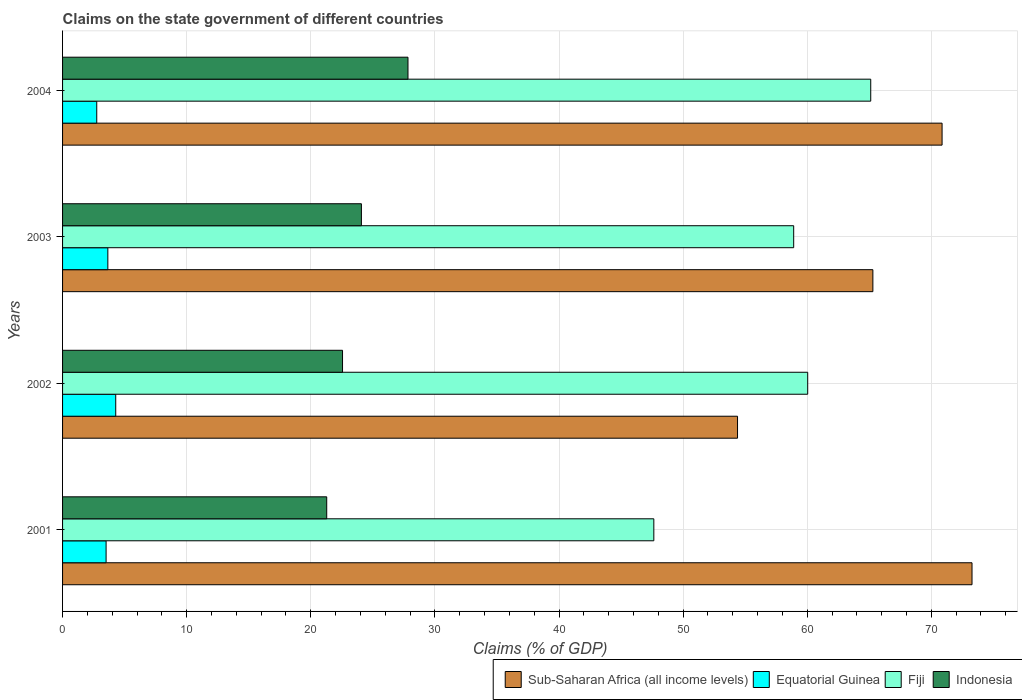How many groups of bars are there?
Offer a terse response. 4. Are the number of bars per tick equal to the number of legend labels?
Make the answer very short. Yes. How many bars are there on the 1st tick from the bottom?
Provide a succinct answer. 4. In how many cases, is the number of bars for a given year not equal to the number of legend labels?
Provide a short and direct response. 0. What is the percentage of GDP claimed on the state government in Sub-Saharan Africa (all income levels) in 2001?
Make the answer very short. 73.28. Across all years, what is the maximum percentage of GDP claimed on the state government in Equatorial Guinea?
Keep it short and to the point. 4.28. Across all years, what is the minimum percentage of GDP claimed on the state government in Indonesia?
Your response must be concise. 21.28. In which year was the percentage of GDP claimed on the state government in Indonesia minimum?
Give a very brief answer. 2001. What is the total percentage of GDP claimed on the state government in Equatorial Guinea in the graph?
Your answer should be very brief. 14.19. What is the difference between the percentage of GDP claimed on the state government in Indonesia in 2001 and that in 2002?
Your response must be concise. -1.27. What is the difference between the percentage of GDP claimed on the state government in Equatorial Guinea in 2001 and the percentage of GDP claimed on the state government in Fiji in 2002?
Offer a very short reply. -56.53. What is the average percentage of GDP claimed on the state government in Sub-Saharan Africa (all income levels) per year?
Offer a very short reply. 65.95. In the year 2004, what is the difference between the percentage of GDP claimed on the state government in Fiji and percentage of GDP claimed on the state government in Sub-Saharan Africa (all income levels)?
Give a very brief answer. -5.75. In how many years, is the percentage of GDP claimed on the state government in Fiji greater than 6 %?
Offer a terse response. 4. What is the ratio of the percentage of GDP claimed on the state government in Fiji in 2003 to that in 2004?
Give a very brief answer. 0.9. What is the difference between the highest and the second highest percentage of GDP claimed on the state government in Fiji?
Make the answer very short. 5.08. What is the difference between the highest and the lowest percentage of GDP claimed on the state government in Fiji?
Provide a succinct answer. 17.48. In how many years, is the percentage of GDP claimed on the state government in Indonesia greater than the average percentage of GDP claimed on the state government in Indonesia taken over all years?
Keep it short and to the point. 2. Is the sum of the percentage of GDP claimed on the state government in Fiji in 2001 and 2003 greater than the maximum percentage of GDP claimed on the state government in Equatorial Guinea across all years?
Provide a succinct answer. Yes. What does the 3rd bar from the top in 2003 represents?
Ensure brevity in your answer.  Equatorial Guinea. What does the 4th bar from the bottom in 2001 represents?
Give a very brief answer. Indonesia. How many bars are there?
Provide a succinct answer. 16. How many years are there in the graph?
Ensure brevity in your answer.  4. What is the difference between two consecutive major ticks on the X-axis?
Offer a very short reply. 10. Are the values on the major ticks of X-axis written in scientific E-notation?
Your answer should be very brief. No. Does the graph contain any zero values?
Your answer should be very brief. No. Where does the legend appear in the graph?
Offer a terse response. Bottom right. How many legend labels are there?
Your answer should be compact. 4. How are the legend labels stacked?
Give a very brief answer. Horizontal. What is the title of the graph?
Give a very brief answer. Claims on the state government of different countries. Does "Russian Federation" appear as one of the legend labels in the graph?
Your answer should be very brief. No. What is the label or title of the X-axis?
Provide a succinct answer. Claims (% of GDP). What is the label or title of the Y-axis?
Your response must be concise. Years. What is the Claims (% of GDP) in Sub-Saharan Africa (all income levels) in 2001?
Your answer should be compact. 73.28. What is the Claims (% of GDP) in Equatorial Guinea in 2001?
Your answer should be compact. 3.51. What is the Claims (% of GDP) in Fiji in 2001?
Make the answer very short. 47.64. What is the Claims (% of GDP) in Indonesia in 2001?
Your response must be concise. 21.28. What is the Claims (% of GDP) in Sub-Saharan Africa (all income levels) in 2002?
Ensure brevity in your answer.  54.38. What is the Claims (% of GDP) in Equatorial Guinea in 2002?
Your answer should be very brief. 4.28. What is the Claims (% of GDP) of Fiji in 2002?
Offer a terse response. 60.04. What is the Claims (% of GDP) of Indonesia in 2002?
Make the answer very short. 22.56. What is the Claims (% of GDP) in Sub-Saharan Africa (all income levels) in 2003?
Your response must be concise. 65.29. What is the Claims (% of GDP) in Equatorial Guinea in 2003?
Your answer should be compact. 3.65. What is the Claims (% of GDP) of Fiji in 2003?
Make the answer very short. 58.91. What is the Claims (% of GDP) in Indonesia in 2003?
Make the answer very short. 24.08. What is the Claims (% of GDP) of Sub-Saharan Africa (all income levels) in 2004?
Keep it short and to the point. 70.86. What is the Claims (% of GDP) in Equatorial Guinea in 2004?
Provide a short and direct response. 2.75. What is the Claims (% of GDP) in Fiji in 2004?
Give a very brief answer. 65.12. What is the Claims (% of GDP) of Indonesia in 2004?
Your response must be concise. 27.83. Across all years, what is the maximum Claims (% of GDP) of Sub-Saharan Africa (all income levels)?
Your answer should be compact. 73.28. Across all years, what is the maximum Claims (% of GDP) in Equatorial Guinea?
Offer a terse response. 4.28. Across all years, what is the maximum Claims (% of GDP) in Fiji?
Your answer should be compact. 65.12. Across all years, what is the maximum Claims (% of GDP) of Indonesia?
Offer a terse response. 27.83. Across all years, what is the minimum Claims (% of GDP) in Sub-Saharan Africa (all income levels)?
Keep it short and to the point. 54.38. Across all years, what is the minimum Claims (% of GDP) of Equatorial Guinea?
Keep it short and to the point. 2.75. Across all years, what is the minimum Claims (% of GDP) in Fiji?
Your response must be concise. 47.64. Across all years, what is the minimum Claims (% of GDP) of Indonesia?
Give a very brief answer. 21.28. What is the total Claims (% of GDP) in Sub-Saharan Africa (all income levels) in the graph?
Give a very brief answer. 263.81. What is the total Claims (% of GDP) of Equatorial Guinea in the graph?
Keep it short and to the point. 14.19. What is the total Claims (% of GDP) of Fiji in the graph?
Keep it short and to the point. 231.7. What is the total Claims (% of GDP) in Indonesia in the graph?
Offer a terse response. 95.75. What is the difference between the Claims (% of GDP) of Sub-Saharan Africa (all income levels) in 2001 and that in 2002?
Ensure brevity in your answer.  18.89. What is the difference between the Claims (% of GDP) of Equatorial Guinea in 2001 and that in 2002?
Make the answer very short. -0.78. What is the difference between the Claims (% of GDP) of Fiji in 2001 and that in 2002?
Make the answer very short. -12.4. What is the difference between the Claims (% of GDP) of Indonesia in 2001 and that in 2002?
Your response must be concise. -1.27. What is the difference between the Claims (% of GDP) of Sub-Saharan Africa (all income levels) in 2001 and that in 2003?
Give a very brief answer. 7.99. What is the difference between the Claims (% of GDP) in Equatorial Guinea in 2001 and that in 2003?
Give a very brief answer. -0.14. What is the difference between the Claims (% of GDP) of Fiji in 2001 and that in 2003?
Offer a very short reply. -11.27. What is the difference between the Claims (% of GDP) in Indonesia in 2001 and that in 2003?
Your answer should be very brief. -2.8. What is the difference between the Claims (% of GDP) of Sub-Saharan Africa (all income levels) in 2001 and that in 2004?
Make the answer very short. 2.41. What is the difference between the Claims (% of GDP) of Equatorial Guinea in 2001 and that in 2004?
Give a very brief answer. 0.75. What is the difference between the Claims (% of GDP) in Fiji in 2001 and that in 2004?
Ensure brevity in your answer.  -17.48. What is the difference between the Claims (% of GDP) in Indonesia in 2001 and that in 2004?
Keep it short and to the point. -6.55. What is the difference between the Claims (% of GDP) in Sub-Saharan Africa (all income levels) in 2002 and that in 2003?
Your answer should be compact. -10.9. What is the difference between the Claims (% of GDP) of Equatorial Guinea in 2002 and that in 2003?
Your answer should be very brief. 0.64. What is the difference between the Claims (% of GDP) in Fiji in 2002 and that in 2003?
Make the answer very short. 1.13. What is the difference between the Claims (% of GDP) of Indonesia in 2002 and that in 2003?
Ensure brevity in your answer.  -1.52. What is the difference between the Claims (% of GDP) in Sub-Saharan Africa (all income levels) in 2002 and that in 2004?
Give a very brief answer. -16.48. What is the difference between the Claims (% of GDP) in Equatorial Guinea in 2002 and that in 2004?
Provide a succinct answer. 1.53. What is the difference between the Claims (% of GDP) of Fiji in 2002 and that in 2004?
Your response must be concise. -5.08. What is the difference between the Claims (% of GDP) in Indonesia in 2002 and that in 2004?
Make the answer very short. -5.27. What is the difference between the Claims (% of GDP) of Sub-Saharan Africa (all income levels) in 2003 and that in 2004?
Offer a terse response. -5.58. What is the difference between the Claims (% of GDP) of Equatorial Guinea in 2003 and that in 2004?
Offer a very short reply. 0.89. What is the difference between the Claims (% of GDP) in Fiji in 2003 and that in 2004?
Ensure brevity in your answer.  -6.21. What is the difference between the Claims (% of GDP) of Indonesia in 2003 and that in 2004?
Make the answer very short. -3.75. What is the difference between the Claims (% of GDP) of Sub-Saharan Africa (all income levels) in 2001 and the Claims (% of GDP) of Equatorial Guinea in 2002?
Offer a very short reply. 68.99. What is the difference between the Claims (% of GDP) of Sub-Saharan Africa (all income levels) in 2001 and the Claims (% of GDP) of Fiji in 2002?
Provide a succinct answer. 13.24. What is the difference between the Claims (% of GDP) of Sub-Saharan Africa (all income levels) in 2001 and the Claims (% of GDP) of Indonesia in 2002?
Your answer should be very brief. 50.72. What is the difference between the Claims (% of GDP) in Equatorial Guinea in 2001 and the Claims (% of GDP) in Fiji in 2002?
Offer a very short reply. -56.53. What is the difference between the Claims (% of GDP) of Equatorial Guinea in 2001 and the Claims (% of GDP) of Indonesia in 2002?
Ensure brevity in your answer.  -19.05. What is the difference between the Claims (% of GDP) of Fiji in 2001 and the Claims (% of GDP) of Indonesia in 2002?
Your response must be concise. 25.08. What is the difference between the Claims (% of GDP) in Sub-Saharan Africa (all income levels) in 2001 and the Claims (% of GDP) in Equatorial Guinea in 2003?
Your response must be concise. 69.63. What is the difference between the Claims (% of GDP) of Sub-Saharan Africa (all income levels) in 2001 and the Claims (% of GDP) of Fiji in 2003?
Ensure brevity in your answer.  14.37. What is the difference between the Claims (% of GDP) of Sub-Saharan Africa (all income levels) in 2001 and the Claims (% of GDP) of Indonesia in 2003?
Offer a very short reply. 49.2. What is the difference between the Claims (% of GDP) in Equatorial Guinea in 2001 and the Claims (% of GDP) in Fiji in 2003?
Make the answer very short. -55.4. What is the difference between the Claims (% of GDP) in Equatorial Guinea in 2001 and the Claims (% of GDP) in Indonesia in 2003?
Offer a very short reply. -20.57. What is the difference between the Claims (% of GDP) in Fiji in 2001 and the Claims (% of GDP) in Indonesia in 2003?
Keep it short and to the point. 23.56. What is the difference between the Claims (% of GDP) of Sub-Saharan Africa (all income levels) in 2001 and the Claims (% of GDP) of Equatorial Guinea in 2004?
Offer a very short reply. 70.52. What is the difference between the Claims (% of GDP) of Sub-Saharan Africa (all income levels) in 2001 and the Claims (% of GDP) of Fiji in 2004?
Provide a short and direct response. 8.16. What is the difference between the Claims (% of GDP) in Sub-Saharan Africa (all income levels) in 2001 and the Claims (% of GDP) in Indonesia in 2004?
Keep it short and to the point. 45.45. What is the difference between the Claims (% of GDP) of Equatorial Guinea in 2001 and the Claims (% of GDP) of Fiji in 2004?
Your answer should be very brief. -61.61. What is the difference between the Claims (% of GDP) of Equatorial Guinea in 2001 and the Claims (% of GDP) of Indonesia in 2004?
Make the answer very short. -24.32. What is the difference between the Claims (% of GDP) in Fiji in 2001 and the Claims (% of GDP) in Indonesia in 2004?
Offer a terse response. 19.81. What is the difference between the Claims (% of GDP) in Sub-Saharan Africa (all income levels) in 2002 and the Claims (% of GDP) in Equatorial Guinea in 2003?
Keep it short and to the point. 50.74. What is the difference between the Claims (% of GDP) of Sub-Saharan Africa (all income levels) in 2002 and the Claims (% of GDP) of Fiji in 2003?
Make the answer very short. -4.52. What is the difference between the Claims (% of GDP) of Sub-Saharan Africa (all income levels) in 2002 and the Claims (% of GDP) of Indonesia in 2003?
Make the answer very short. 30.31. What is the difference between the Claims (% of GDP) in Equatorial Guinea in 2002 and the Claims (% of GDP) in Fiji in 2003?
Make the answer very short. -54.62. What is the difference between the Claims (% of GDP) of Equatorial Guinea in 2002 and the Claims (% of GDP) of Indonesia in 2003?
Offer a terse response. -19.79. What is the difference between the Claims (% of GDP) of Fiji in 2002 and the Claims (% of GDP) of Indonesia in 2003?
Make the answer very short. 35.96. What is the difference between the Claims (% of GDP) of Sub-Saharan Africa (all income levels) in 2002 and the Claims (% of GDP) of Equatorial Guinea in 2004?
Make the answer very short. 51.63. What is the difference between the Claims (% of GDP) in Sub-Saharan Africa (all income levels) in 2002 and the Claims (% of GDP) in Fiji in 2004?
Keep it short and to the point. -10.73. What is the difference between the Claims (% of GDP) in Sub-Saharan Africa (all income levels) in 2002 and the Claims (% of GDP) in Indonesia in 2004?
Your response must be concise. 26.55. What is the difference between the Claims (% of GDP) of Equatorial Guinea in 2002 and the Claims (% of GDP) of Fiji in 2004?
Keep it short and to the point. -60.83. What is the difference between the Claims (% of GDP) in Equatorial Guinea in 2002 and the Claims (% of GDP) in Indonesia in 2004?
Keep it short and to the point. -23.55. What is the difference between the Claims (% of GDP) in Fiji in 2002 and the Claims (% of GDP) in Indonesia in 2004?
Give a very brief answer. 32.21. What is the difference between the Claims (% of GDP) of Sub-Saharan Africa (all income levels) in 2003 and the Claims (% of GDP) of Equatorial Guinea in 2004?
Offer a terse response. 62.53. What is the difference between the Claims (% of GDP) in Sub-Saharan Africa (all income levels) in 2003 and the Claims (% of GDP) in Fiji in 2004?
Offer a very short reply. 0.17. What is the difference between the Claims (% of GDP) of Sub-Saharan Africa (all income levels) in 2003 and the Claims (% of GDP) of Indonesia in 2004?
Make the answer very short. 37.46. What is the difference between the Claims (% of GDP) of Equatorial Guinea in 2003 and the Claims (% of GDP) of Fiji in 2004?
Give a very brief answer. -61.47. What is the difference between the Claims (% of GDP) in Equatorial Guinea in 2003 and the Claims (% of GDP) in Indonesia in 2004?
Ensure brevity in your answer.  -24.18. What is the difference between the Claims (% of GDP) in Fiji in 2003 and the Claims (% of GDP) in Indonesia in 2004?
Your answer should be very brief. 31.08. What is the average Claims (% of GDP) in Sub-Saharan Africa (all income levels) per year?
Your answer should be compact. 65.95. What is the average Claims (% of GDP) in Equatorial Guinea per year?
Your response must be concise. 3.55. What is the average Claims (% of GDP) in Fiji per year?
Your answer should be compact. 57.93. What is the average Claims (% of GDP) in Indonesia per year?
Offer a terse response. 23.94. In the year 2001, what is the difference between the Claims (% of GDP) of Sub-Saharan Africa (all income levels) and Claims (% of GDP) of Equatorial Guinea?
Your response must be concise. 69.77. In the year 2001, what is the difference between the Claims (% of GDP) in Sub-Saharan Africa (all income levels) and Claims (% of GDP) in Fiji?
Make the answer very short. 25.64. In the year 2001, what is the difference between the Claims (% of GDP) of Sub-Saharan Africa (all income levels) and Claims (% of GDP) of Indonesia?
Offer a terse response. 51.99. In the year 2001, what is the difference between the Claims (% of GDP) of Equatorial Guinea and Claims (% of GDP) of Fiji?
Offer a terse response. -44.13. In the year 2001, what is the difference between the Claims (% of GDP) of Equatorial Guinea and Claims (% of GDP) of Indonesia?
Offer a terse response. -17.78. In the year 2001, what is the difference between the Claims (% of GDP) of Fiji and Claims (% of GDP) of Indonesia?
Keep it short and to the point. 26.36. In the year 2002, what is the difference between the Claims (% of GDP) of Sub-Saharan Africa (all income levels) and Claims (% of GDP) of Equatorial Guinea?
Provide a short and direct response. 50.1. In the year 2002, what is the difference between the Claims (% of GDP) in Sub-Saharan Africa (all income levels) and Claims (% of GDP) in Fiji?
Ensure brevity in your answer.  -5.65. In the year 2002, what is the difference between the Claims (% of GDP) in Sub-Saharan Africa (all income levels) and Claims (% of GDP) in Indonesia?
Your answer should be very brief. 31.83. In the year 2002, what is the difference between the Claims (% of GDP) of Equatorial Guinea and Claims (% of GDP) of Fiji?
Your response must be concise. -55.75. In the year 2002, what is the difference between the Claims (% of GDP) of Equatorial Guinea and Claims (% of GDP) of Indonesia?
Your answer should be compact. -18.27. In the year 2002, what is the difference between the Claims (% of GDP) of Fiji and Claims (% of GDP) of Indonesia?
Your answer should be compact. 37.48. In the year 2003, what is the difference between the Claims (% of GDP) in Sub-Saharan Africa (all income levels) and Claims (% of GDP) in Equatorial Guinea?
Provide a short and direct response. 61.64. In the year 2003, what is the difference between the Claims (% of GDP) in Sub-Saharan Africa (all income levels) and Claims (% of GDP) in Fiji?
Provide a short and direct response. 6.38. In the year 2003, what is the difference between the Claims (% of GDP) in Sub-Saharan Africa (all income levels) and Claims (% of GDP) in Indonesia?
Offer a terse response. 41.21. In the year 2003, what is the difference between the Claims (% of GDP) of Equatorial Guinea and Claims (% of GDP) of Fiji?
Keep it short and to the point. -55.26. In the year 2003, what is the difference between the Claims (% of GDP) of Equatorial Guinea and Claims (% of GDP) of Indonesia?
Offer a very short reply. -20.43. In the year 2003, what is the difference between the Claims (% of GDP) of Fiji and Claims (% of GDP) of Indonesia?
Provide a short and direct response. 34.83. In the year 2004, what is the difference between the Claims (% of GDP) in Sub-Saharan Africa (all income levels) and Claims (% of GDP) in Equatorial Guinea?
Provide a succinct answer. 68.11. In the year 2004, what is the difference between the Claims (% of GDP) of Sub-Saharan Africa (all income levels) and Claims (% of GDP) of Fiji?
Your answer should be compact. 5.75. In the year 2004, what is the difference between the Claims (% of GDP) of Sub-Saharan Africa (all income levels) and Claims (% of GDP) of Indonesia?
Provide a short and direct response. 43.03. In the year 2004, what is the difference between the Claims (% of GDP) in Equatorial Guinea and Claims (% of GDP) in Fiji?
Keep it short and to the point. -62.36. In the year 2004, what is the difference between the Claims (% of GDP) in Equatorial Guinea and Claims (% of GDP) in Indonesia?
Your answer should be compact. -25.08. In the year 2004, what is the difference between the Claims (% of GDP) of Fiji and Claims (% of GDP) of Indonesia?
Offer a very short reply. 37.29. What is the ratio of the Claims (% of GDP) of Sub-Saharan Africa (all income levels) in 2001 to that in 2002?
Provide a short and direct response. 1.35. What is the ratio of the Claims (% of GDP) of Equatorial Guinea in 2001 to that in 2002?
Make the answer very short. 0.82. What is the ratio of the Claims (% of GDP) in Fiji in 2001 to that in 2002?
Offer a very short reply. 0.79. What is the ratio of the Claims (% of GDP) in Indonesia in 2001 to that in 2002?
Offer a very short reply. 0.94. What is the ratio of the Claims (% of GDP) of Sub-Saharan Africa (all income levels) in 2001 to that in 2003?
Provide a succinct answer. 1.12. What is the ratio of the Claims (% of GDP) in Equatorial Guinea in 2001 to that in 2003?
Your answer should be very brief. 0.96. What is the ratio of the Claims (% of GDP) of Fiji in 2001 to that in 2003?
Provide a succinct answer. 0.81. What is the ratio of the Claims (% of GDP) of Indonesia in 2001 to that in 2003?
Offer a very short reply. 0.88. What is the ratio of the Claims (% of GDP) of Sub-Saharan Africa (all income levels) in 2001 to that in 2004?
Provide a succinct answer. 1.03. What is the ratio of the Claims (% of GDP) of Equatorial Guinea in 2001 to that in 2004?
Provide a short and direct response. 1.27. What is the ratio of the Claims (% of GDP) of Fiji in 2001 to that in 2004?
Provide a short and direct response. 0.73. What is the ratio of the Claims (% of GDP) in Indonesia in 2001 to that in 2004?
Make the answer very short. 0.76. What is the ratio of the Claims (% of GDP) of Sub-Saharan Africa (all income levels) in 2002 to that in 2003?
Ensure brevity in your answer.  0.83. What is the ratio of the Claims (% of GDP) of Equatorial Guinea in 2002 to that in 2003?
Make the answer very short. 1.17. What is the ratio of the Claims (% of GDP) of Fiji in 2002 to that in 2003?
Keep it short and to the point. 1.02. What is the ratio of the Claims (% of GDP) in Indonesia in 2002 to that in 2003?
Provide a succinct answer. 0.94. What is the ratio of the Claims (% of GDP) in Sub-Saharan Africa (all income levels) in 2002 to that in 2004?
Your answer should be compact. 0.77. What is the ratio of the Claims (% of GDP) in Equatorial Guinea in 2002 to that in 2004?
Keep it short and to the point. 1.56. What is the ratio of the Claims (% of GDP) in Fiji in 2002 to that in 2004?
Give a very brief answer. 0.92. What is the ratio of the Claims (% of GDP) in Indonesia in 2002 to that in 2004?
Provide a succinct answer. 0.81. What is the ratio of the Claims (% of GDP) of Sub-Saharan Africa (all income levels) in 2003 to that in 2004?
Ensure brevity in your answer.  0.92. What is the ratio of the Claims (% of GDP) of Equatorial Guinea in 2003 to that in 2004?
Provide a succinct answer. 1.32. What is the ratio of the Claims (% of GDP) of Fiji in 2003 to that in 2004?
Give a very brief answer. 0.9. What is the ratio of the Claims (% of GDP) in Indonesia in 2003 to that in 2004?
Make the answer very short. 0.87. What is the difference between the highest and the second highest Claims (% of GDP) of Sub-Saharan Africa (all income levels)?
Your answer should be compact. 2.41. What is the difference between the highest and the second highest Claims (% of GDP) in Equatorial Guinea?
Offer a terse response. 0.64. What is the difference between the highest and the second highest Claims (% of GDP) of Fiji?
Ensure brevity in your answer.  5.08. What is the difference between the highest and the second highest Claims (% of GDP) of Indonesia?
Offer a very short reply. 3.75. What is the difference between the highest and the lowest Claims (% of GDP) in Sub-Saharan Africa (all income levels)?
Your answer should be compact. 18.89. What is the difference between the highest and the lowest Claims (% of GDP) of Equatorial Guinea?
Give a very brief answer. 1.53. What is the difference between the highest and the lowest Claims (% of GDP) in Fiji?
Give a very brief answer. 17.48. What is the difference between the highest and the lowest Claims (% of GDP) in Indonesia?
Your answer should be very brief. 6.55. 